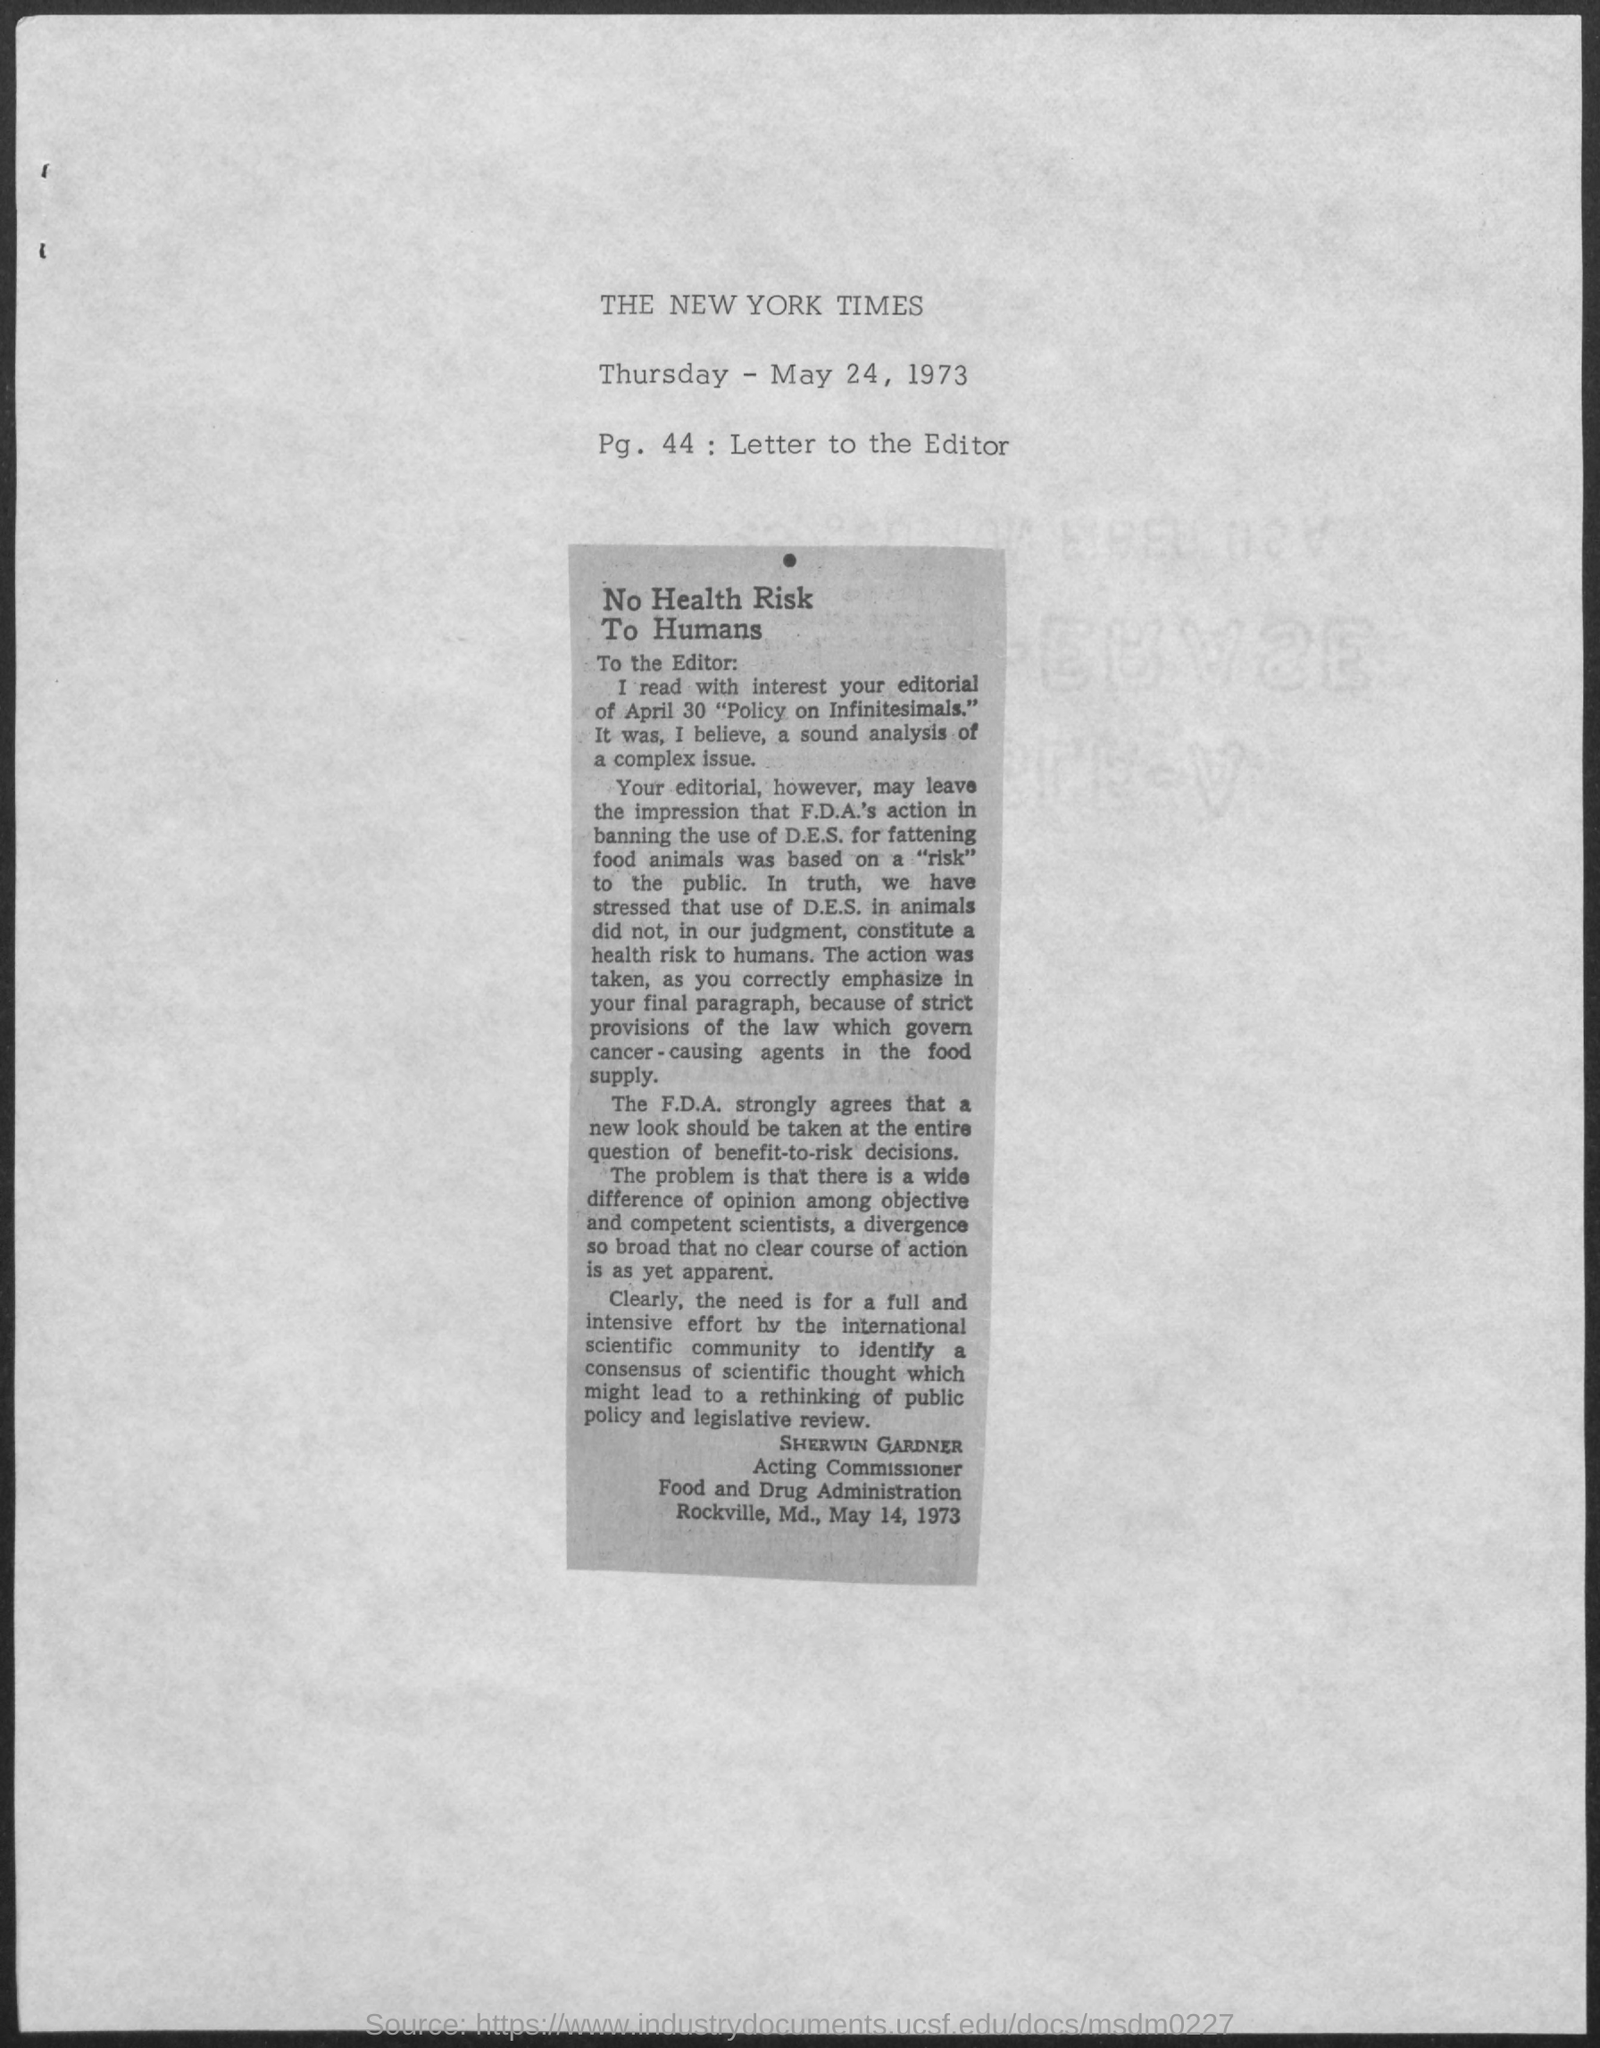Outline some significant characteristics in this image. The date on the document is May 24, 1973. 